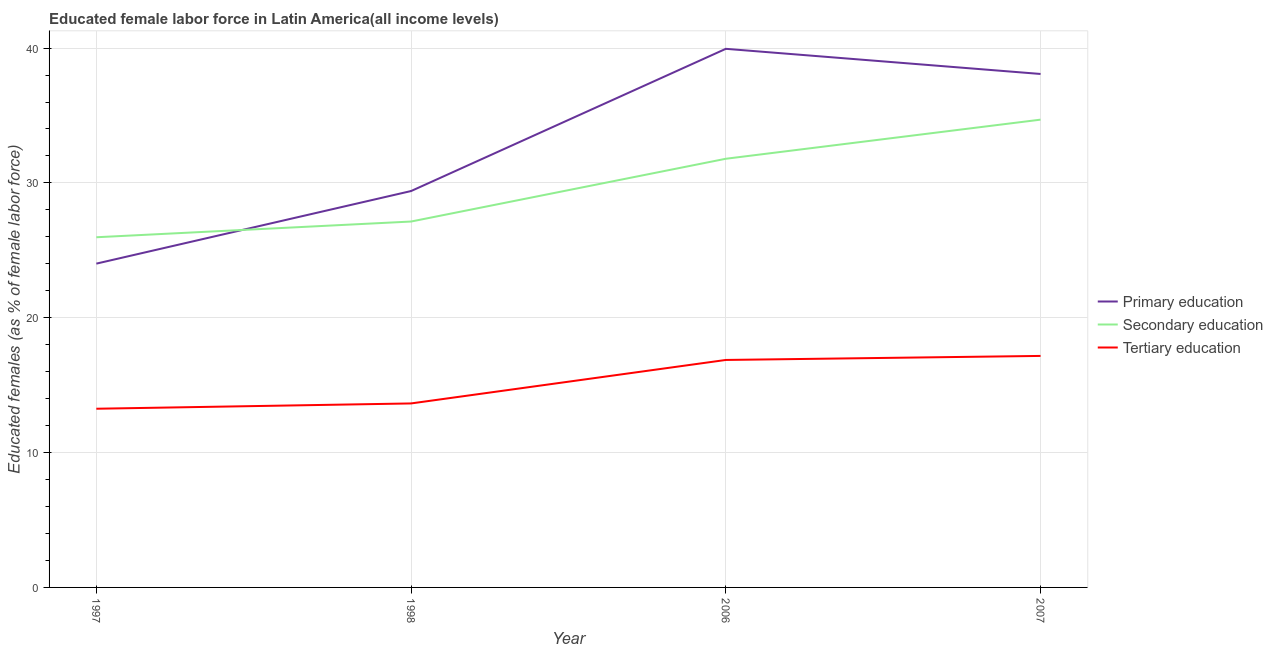What is the percentage of female labor force who received tertiary education in 2007?
Your answer should be very brief. 17.17. Across all years, what is the maximum percentage of female labor force who received tertiary education?
Provide a short and direct response. 17.17. Across all years, what is the minimum percentage of female labor force who received secondary education?
Your response must be concise. 25.97. In which year was the percentage of female labor force who received tertiary education minimum?
Make the answer very short. 1997. What is the total percentage of female labor force who received secondary education in the graph?
Your answer should be very brief. 119.59. What is the difference between the percentage of female labor force who received primary education in 1998 and that in 2007?
Provide a succinct answer. -8.68. What is the difference between the percentage of female labor force who received secondary education in 1997 and the percentage of female labor force who received tertiary education in 2006?
Provide a short and direct response. 9.1. What is the average percentage of female labor force who received primary education per year?
Provide a succinct answer. 32.86. In the year 2006, what is the difference between the percentage of female labor force who received tertiary education and percentage of female labor force who received secondary education?
Make the answer very short. -14.92. In how many years, is the percentage of female labor force who received tertiary education greater than 30 %?
Your response must be concise. 0. What is the ratio of the percentage of female labor force who received tertiary education in 1997 to that in 2007?
Provide a short and direct response. 0.77. Is the percentage of female labor force who received secondary education in 1998 less than that in 2006?
Offer a terse response. Yes. What is the difference between the highest and the second highest percentage of female labor force who received tertiary education?
Make the answer very short. 0.3. What is the difference between the highest and the lowest percentage of female labor force who received primary education?
Your response must be concise. 15.93. Is the sum of the percentage of female labor force who received tertiary education in 1997 and 2006 greater than the maximum percentage of female labor force who received secondary education across all years?
Your response must be concise. No. Is it the case that in every year, the sum of the percentage of female labor force who received primary education and percentage of female labor force who received secondary education is greater than the percentage of female labor force who received tertiary education?
Provide a succinct answer. Yes. Does the percentage of female labor force who received secondary education monotonically increase over the years?
Keep it short and to the point. Yes. Is the percentage of female labor force who received tertiary education strictly greater than the percentage of female labor force who received primary education over the years?
Provide a short and direct response. No. How many lines are there?
Offer a terse response. 3. How many legend labels are there?
Your answer should be very brief. 3. What is the title of the graph?
Keep it short and to the point. Educated female labor force in Latin America(all income levels). Does "Ages 0-14" appear as one of the legend labels in the graph?
Provide a short and direct response. No. What is the label or title of the Y-axis?
Provide a short and direct response. Educated females (as % of female labor force). What is the Educated females (as % of female labor force) of Primary education in 1997?
Your response must be concise. 24.01. What is the Educated females (as % of female labor force) of Secondary education in 1997?
Make the answer very short. 25.97. What is the Educated females (as % of female labor force) in Tertiary education in 1997?
Offer a terse response. 13.25. What is the Educated females (as % of female labor force) of Primary education in 1998?
Your response must be concise. 29.4. What is the Educated females (as % of female labor force) of Secondary education in 1998?
Provide a succinct answer. 27.14. What is the Educated females (as % of female labor force) in Tertiary education in 1998?
Ensure brevity in your answer.  13.65. What is the Educated females (as % of female labor force) in Primary education in 2006?
Your response must be concise. 39.95. What is the Educated females (as % of female labor force) of Secondary education in 2006?
Your response must be concise. 31.79. What is the Educated females (as % of female labor force) of Tertiary education in 2006?
Make the answer very short. 16.87. What is the Educated females (as % of female labor force) in Primary education in 2007?
Your answer should be compact. 38.08. What is the Educated females (as % of female labor force) of Secondary education in 2007?
Give a very brief answer. 34.69. What is the Educated females (as % of female labor force) of Tertiary education in 2007?
Offer a terse response. 17.17. Across all years, what is the maximum Educated females (as % of female labor force) in Primary education?
Give a very brief answer. 39.95. Across all years, what is the maximum Educated females (as % of female labor force) in Secondary education?
Provide a short and direct response. 34.69. Across all years, what is the maximum Educated females (as % of female labor force) of Tertiary education?
Keep it short and to the point. 17.17. Across all years, what is the minimum Educated females (as % of female labor force) in Primary education?
Offer a terse response. 24.01. Across all years, what is the minimum Educated females (as % of female labor force) in Secondary education?
Offer a terse response. 25.97. Across all years, what is the minimum Educated females (as % of female labor force) in Tertiary education?
Your answer should be compact. 13.25. What is the total Educated females (as % of female labor force) in Primary education in the graph?
Keep it short and to the point. 131.44. What is the total Educated females (as % of female labor force) of Secondary education in the graph?
Provide a short and direct response. 119.59. What is the total Educated females (as % of female labor force) in Tertiary education in the graph?
Give a very brief answer. 60.94. What is the difference between the Educated females (as % of female labor force) of Primary education in 1997 and that in 1998?
Keep it short and to the point. -5.38. What is the difference between the Educated females (as % of female labor force) of Secondary education in 1997 and that in 1998?
Provide a short and direct response. -1.17. What is the difference between the Educated females (as % of female labor force) in Tertiary education in 1997 and that in 1998?
Offer a terse response. -0.39. What is the difference between the Educated females (as % of female labor force) in Primary education in 1997 and that in 2006?
Make the answer very short. -15.93. What is the difference between the Educated females (as % of female labor force) in Secondary education in 1997 and that in 2006?
Provide a succinct answer. -5.82. What is the difference between the Educated females (as % of female labor force) of Tertiary education in 1997 and that in 2006?
Keep it short and to the point. -3.62. What is the difference between the Educated females (as % of female labor force) of Primary education in 1997 and that in 2007?
Your response must be concise. -14.07. What is the difference between the Educated females (as % of female labor force) of Secondary education in 1997 and that in 2007?
Provide a succinct answer. -8.72. What is the difference between the Educated females (as % of female labor force) of Tertiary education in 1997 and that in 2007?
Offer a terse response. -3.92. What is the difference between the Educated females (as % of female labor force) of Primary education in 1998 and that in 2006?
Ensure brevity in your answer.  -10.55. What is the difference between the Educated females (as % of female labor force) in Secondary education in 1998 and that in 2006?
Your answer should be very brief. -4.66. What is the difference between the Educated females (as % of female labor force) of Tertiary education in 1998 and that in 2006?
Keep it short and to the point. -3.22. What is the difference between the Educated females (as % of female labor force) of Primary education in 1998 and that in 2007?
Give a very brief answer. -8.68. What is the difference between the Educated females (as % of female labor force) in Secondary education in 1998 and that in 2007?
Give a very brief answer. -7.56. What is the difference between the Educated females (as % of female labor force) in Tertiary education in 1998 and that in 2007?
Ensure brevity in your answer.  -3.52. What is the difference between the Educated females (as % of female labor force) of Primary education in 2006 and that in 2007?
Your answer should be very brief. 1.87. What is the difference between the Educated females (as % of female labor force) in Secondary education in 2006 and that in 2007?
Give a very brief answer. -2.9. What is the difference between the Educated females (as % of female labor force) in Tertiary education in 2006 and that in 2007?
Offer a very short reply. -0.3. What is the difference between the Educated females (as % of female labor force) of Primary education in 1997 and the Educated females (as % of female labor force) of Secondary education in 1998?
Your answer should be compact. -3.12. What is the difference between the Educated females (as % of female labor force) of Primary education in 1997 and the Educated females (as % of female labor force) of Tertiary education in 1998?
Make the answer very short. 10.37. What is the difference between the Educated females (as % of female labor force) of Secondary education in 1997 and the Educated females (as % of female labor force) of Tertiary education in 1998?
Provide a succinct answer. 12.32. What is the difference between the Educated females (as % of female labor force) in Primary education in 1997 and the Educated females (as % of female labor force) in Secondary education in 2006?
Provide a succinct answer. -7.78. What is the difference between the Educated females (as % of female labor force) in Primary education in 1997 and the Educated females (as % of female labor force) in Tertiary education in 2006?
Offer a terse response. 7.14. What is the difference between the Educated females (as % of female labor force) in Secondary education in 1997 and the Educated females (as % of female labor force) in Tertiary education in 2006?
Provide a short and direct response. 9.1. What is the difference between the Educated females (as % of female labor force) in Primary education in 1997 and the Educated females (as % of female labor force) in Secondary education in 2007?
Your answer should be very brief. -10.68. What is the difference between the Educated females (as % of female labor force) of Primary education in 1997 and the Educated females (as % of female labor force) of Tertiary education in 2007?
Your answer should be very brief. 6.84. What is the difference between the Educated females (as % of female labor force) of Secondary education in 1997 and the Educated females (as % of female labor force) of Tertiary education in 2007?
Your answer should be compact. 8.8. What is the difference between the Educated females (as % of female labor force) in Primary education in 1998 and the Educated females (as % of female labor force) in Secondary education in 2006?
Provide a short and direct response. -2.39. What is the difference between the Educated females (as % of female labor force) in Primary education in 1998 and the Educated females (as % of female labor force) in Tertiary education in 2006?
Ensure brevity in your answer.  12.53. What is the difference between the Educated females (as % of female labor force) of Secondary education in 1998 and the Educated females (as % of female labor force) of Tertiary education in 2006?
Your response must be concise. 10.27. What is the difference between the Educated females (as % of female labor force) in Primary education in 1998 and the Educated females (as % of female labor force) in Secondary education in 2007?
Provide a succinct answer. -5.29. What is the difference between the Educated females (as % of female labor force) of Primary education in 1998 and the Educated females (as % of female labor force) of Tertiary education in 2007?
Provide a short and direct response. 12.23. What is the difference between the Educated females (as % of female labor force) in Secondary education in 1998 and the Educated females (as % of female labor force) in Tertiary education in 2007?
Your answer should be compact. 9.97. What is the difference between the Educated females (as % of female labor force) in Primary education in 2006 and the Educated females (as % of female labor force) in Secondary education in 2007?
Give a very brief answer. 5.25. What is the difference between the Educated females (as % of female labor force) of Primary education in 2006 and the Educated females (as % of female labor force) of Tertiary education in 2007?
Your response must be concise. 22.78. What is the difference between the Educated females (as % of female labor force) of Secondary education in 2006 and the Educated females (as % of female labor force) of Tertiary education in 2007?
Your answer should be very brief. 14.62. What is the average Educated females (as % of female labor force) of Primary education per year?
Offer a very short reply. 32.86. What is the average Educated females (as % of female labor force) of Secondary education per year?
Ensure brevity in your answer.  29.9. What is the average Educated females (as % of female labor force) of Tertiary education per year?
Provide a succinct answer. 15.23. In the year 1997, what is the difference between the Educated females (as % of female labor force) in Primary education and Educated females (as % of female labor force) in Secondary education?
Offer a terse response. -1.96. In the year 1997, what is the difference between the Educated females (as % of female labor force) in Primary education and Educated females (as % of female labor force) in Tertiary education?
Keep it short and to the point. 10.76. In the year 1997, what is the difference between the Educated females (as % of female labor force) in Secondary education and Educated females (as % of female labor force) in Tertiary education?
Your response must be concise. 12.72. In the year 1998, what is the difference between the Educated females (as % of female labor force) in Primary education and Educated females (as % of female labor force) in Secondary education?
Your answer should be very brief. 2.26. In the year 1998, what is the difference between the Educated females (as % of female labor force) of Primary education and Educated females (as % of female labor force) of Tertiary education?
Provide a short and direct response. 15.75. In the year 1998, what is the difference between the Educated females (as % of female labor force) of Secondary education and Educated females (as % of female labor force) of Tertiary education?
Offer a very short reply. 13.49. In the year 2006, what is the difference between the Educated females (as % of female labor force) of Primary education and Educated females (as % of female labor force) of Secondary education?
Offer a very short reply. 8.15. In the year 2006, what is the difference between the Educated females (as % of female labor force) of Primary education and Educated females (as % of female labor force) of Tertiary education?
Offer a terse response. 23.07. In the year 2006, what is the difference between the Educated females (as % of female labor force) of Secondary education and Educated females (as % of female labor force) of Tertiary education?
Offer a very short reply. 14.92. In the year 2007, what is the difference between the Educated females (as % of female labor force) in Primary education and Educated females (as % of female labor force) in Secondary education?
Offer a terse response. 3.39. In the year 2007, what is the difference between the Educated females (as % of female labor force) in Primary education and Educated females (as % of female labor force) in Tertiary education?
Provide a short and direct response. 20.91. In the year 2007, what is the difference between the Educated females (as % of female labor force) in Secondary education and Educated females (as % of female labor force) in Tertiary education?
Your answer should be compact. 17.52. What is the ratio of the Educated females (as % of female labor force) of Primary education in 1997 to that in 1998?
Offer a very short reply. 0.82. What is the ratio of the Educated females (as % of female labor force) in Tertiary education in 1997 to that in 1998?
Provide a succinct answer. 0.97. What is the ratio of the Educated females (as % of female labor force) in Primary education in 1997 to that in 2006?
Give a very brief answer. 0.6. What is the ratio of the Educated females (as % of female labor force) of Secondary education in 1997 to that in 2006?
Provide a short and direct response. 0.82. What is the ratio of the Educated females (as % of female labor force) in Tertiary education in 1997 to that in 2006?
Keep it short and to the point. 0.79. What is the ratio of the Educated females (as % of female labor force) in Primary education in 1997 to that in 2007?
Provide a short and direct response. 0.63. What is the ratio of the Educated females (as % of female labor force) in Secondary education in 1997 to that in 2007?
Your answer should be very brief. 0.75. What is the ratio of the Educated females (as % of female labor force) in Tertiary education in 1997 to that in 2007?
Provide a succinct answer. 0.77. What is the ratio of the Educated females (as % of female labor force) of Primary education in 1998 to that in 2006?
Provide a short and direct response. 0.74. What is the ratio of the Educated females (as % of female labor force) in Secondary education in 1998 to that in 2006?
Provide a succinct answer. 0.85. What is the ratio of the Educated females (as % of female labor force) in Tertiary education in 1998 to that in 2006?
Your response must be concise. 0.81. What is the ratio of the Educated females (as % of female labor force) of Primary education in 1998 to that in 2007?
Provide a succinct answer. 0.77. What is the ratio of the Educated females (as % of female labor force) in Secondary education in 1998 to that in 2007?
Keep it short and to the point. 0.78. What is the ratio of the Educated females (as % of female labor force) in Tertiary education in 1998 to that in 2007?
Provide a succinct answer. 0.79. What is the ratio of the Educated females (as % of female labor force) of Primary education in 2006 to that in 2007?
Your answer should be very brief. 1.05. What is the ratio of the Educated females (as % of female labor force) in Secondary education in 2006 to that in 2007?
Give a very brief answer. 0.92. What is the ratio of the Educated females (as % of female labor force) of Tertiary education in 2006 to that in 2007?
Ensure brevity in your answer.  0.98. What is the difference between the highest and the second highest Educated females (as % of female labor force) of Primary education?
Provide a succinct answer. 1.87. What is the difference between the highest and the second highest Educated females (as % of female labor force) of Secondary education?
Your response must be concise. 2.9. What is the difference between the highest and the second highest Educated females (as % of female labor force) in Tertiary education?
Make the answer very short. 0.3. What is the difference between the highest and the lowest Educated females (as % of female labor force) of Primary education?
Give a very brief answer. 15.93. What is the difference between the highest and the lowest Educated females (as % of female labor force) in Secondary education?
Offer a terse response. 8.72. What is the difference between the highest and the lowest Educated females (as % of female labor force) of Tertiary education?
Give a very brief answer. 3.92. 